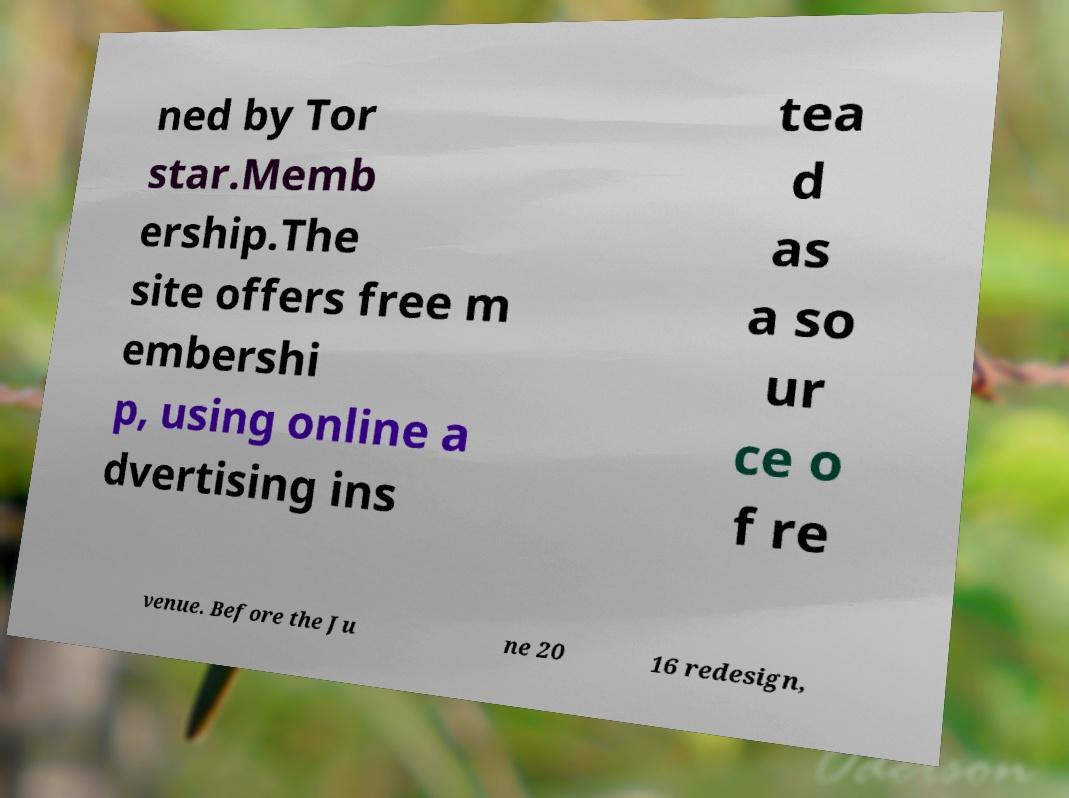Please identify and transcribe the text found in this image. ned by Tor star.Memb ership.The site offers free m embershi p, using online a dvertising ins tea d as a so ur ce o f re venue. Before the Ju ne 20 16 redesign, 